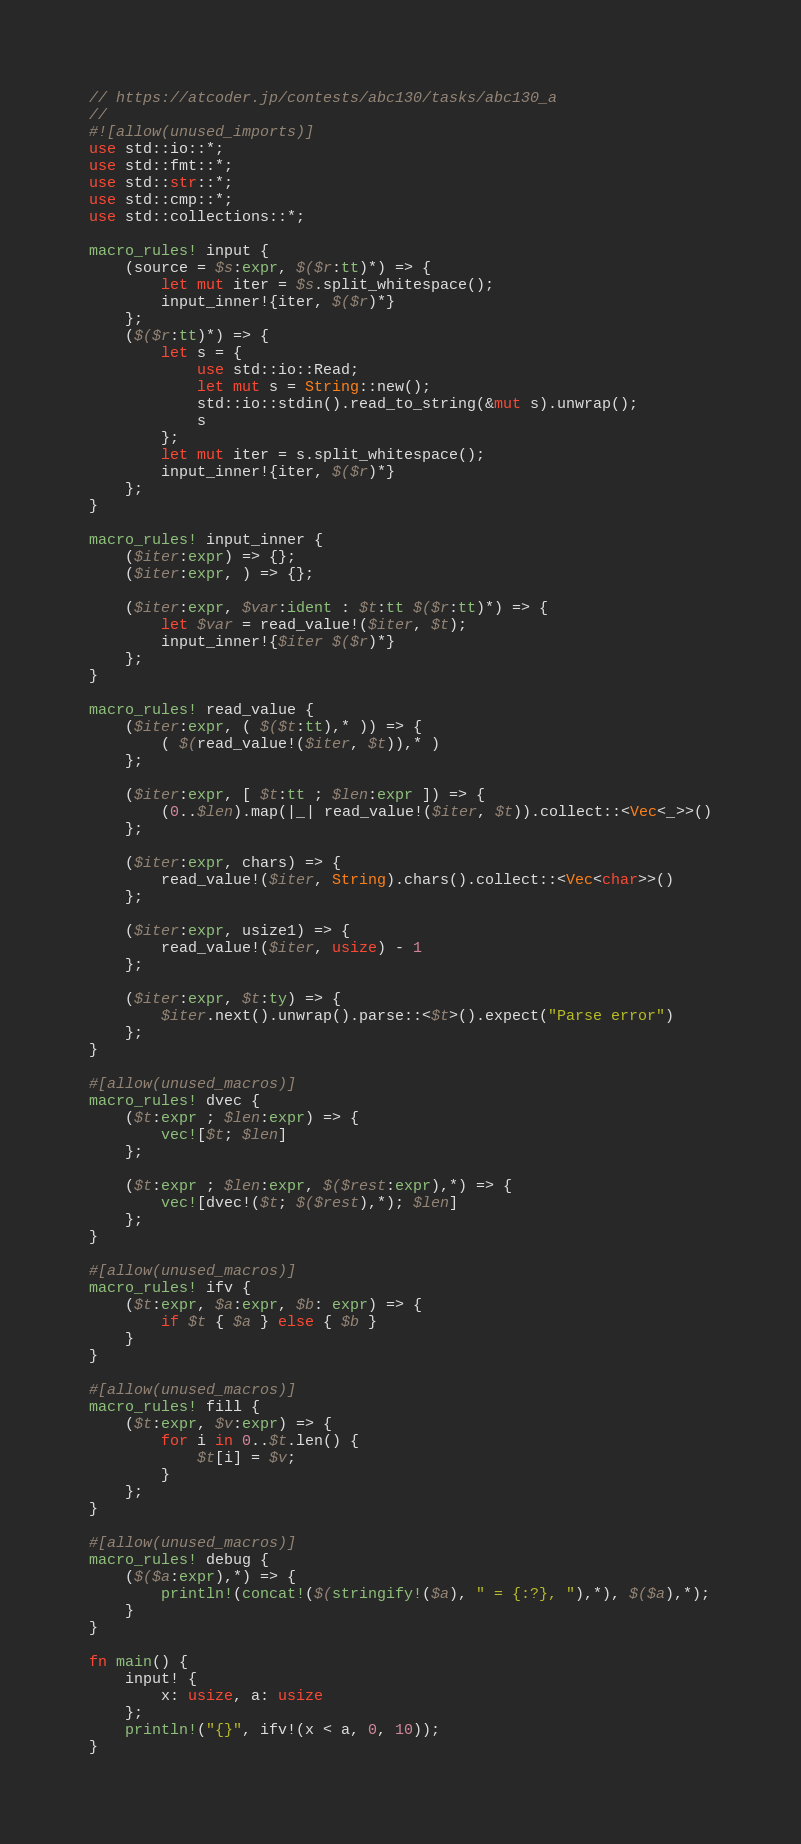<code> <loc_0><loc_0><loc_500><loc_500><_Rust_>// https://atcoder.jp/contests/abc130/tasks/abc130_a
//
#![allow(unused_imports)]
use std::io::*;
use std::fmt::*;
use std::str::*;
use std::cmp::*;
use std::collections::*;

macro_rules! input {
    (source = $s:expr, $($r:tt)*) => {
        let mut iter = $s.split_whitespace();
        input_inner!{iter, $($r)*}
    };
    ($($r:tt)*) => {
        let s = {
            use std::io::Read;
            let mut s = String::new();
            std::io::stdin().read_to_string(&mut s).unwrap();
            s
        };
        let mut iter = s.split_whitespace();
        input_inner!{iter, $($r)*}
    };
}

macro_rules! input_inner {
    ($iter:expr) => {};
    ($iter:expr, ) => {};

    ($iter:expr, $var:ident : $t:tt $($r:tt)*) => {
        let $var = read_value!($iter, $t);
        input_inner!{$iter $($r)*}
    };
}

macro_rules! read_value {
    ($iter:expr, ( $($t:tt),* )) => {
        ( $(read_value!($iter, $t)),* )
    };

    ($iter:expr, [ $t:tt ; $len:expr ]) => {
        (0..$len).map(|_| read_value!($iter, $t)).collect::<Vec<_>>()
    };

    ($iter:expr, chars) => {
        read_value!($iter, String).chars().collect::<Vec<char>>()
    };

    ($iter:expr, usize1) => {
        read_value!($iter, usize) - 1
    };

    ($iter:expr, $t:ty) => {
        $iter.next().unwrap().parse::<$t>().expect("Parse error")
    };
}

#[allow(unused_macros)]
macro_rules! dvec {
    ($t:expr ; $len:expr) => {
        vec![$t; $len]
    };

    ($t:expr ; $len:expr, $($rest:expr),*) => {
        vec![dvec!($t; $($rest),*); $len]
    };
}

#[allow(unused_macros)]
macro_rules! ifv {
    ($t:expr, $a:expr, $b: expr) => {
        if $t { $a } else { $b }
    }
}

#[allow(unused_macros)]
macro_rules! fill {
    ($t:expr, $v:expr) => {
        for i in 0..$t.len() {
            $t[i] = $v;
        }
    };
}

#[allow(unused_macros)]
macro_rules! debug {
    ($($a:expr),*) => {
        println!(concat!($(stringify!($a), " = {:?}, "),*), $($a),*);
    }
}

fn main() {
    input! {
        x: usize, a: usize
    };
    println!("{}", ifv!(x < a, 0, 10));
}
</code> 